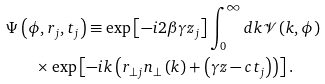<formula> <loc_0><loc_0><loc_500><loc_500>\Psi & \left ( \phi , r _ { j } , t _ { j } \right ) \equiv \exp \left [ - i 2 \beta \gamma z _ { j } \right ] \int _ { 0 } ^ { \infty } d k \mathcal { V } \left ( k , \phi \right ) \\ & \quad \times \exp \left [ - i k \left ( r _ { \bot j } n _ { \bot } \left ( k \right ) + \left ( \gamma z - c t _ { j } \right ) \right ) \right ] \text {.}</formula> 